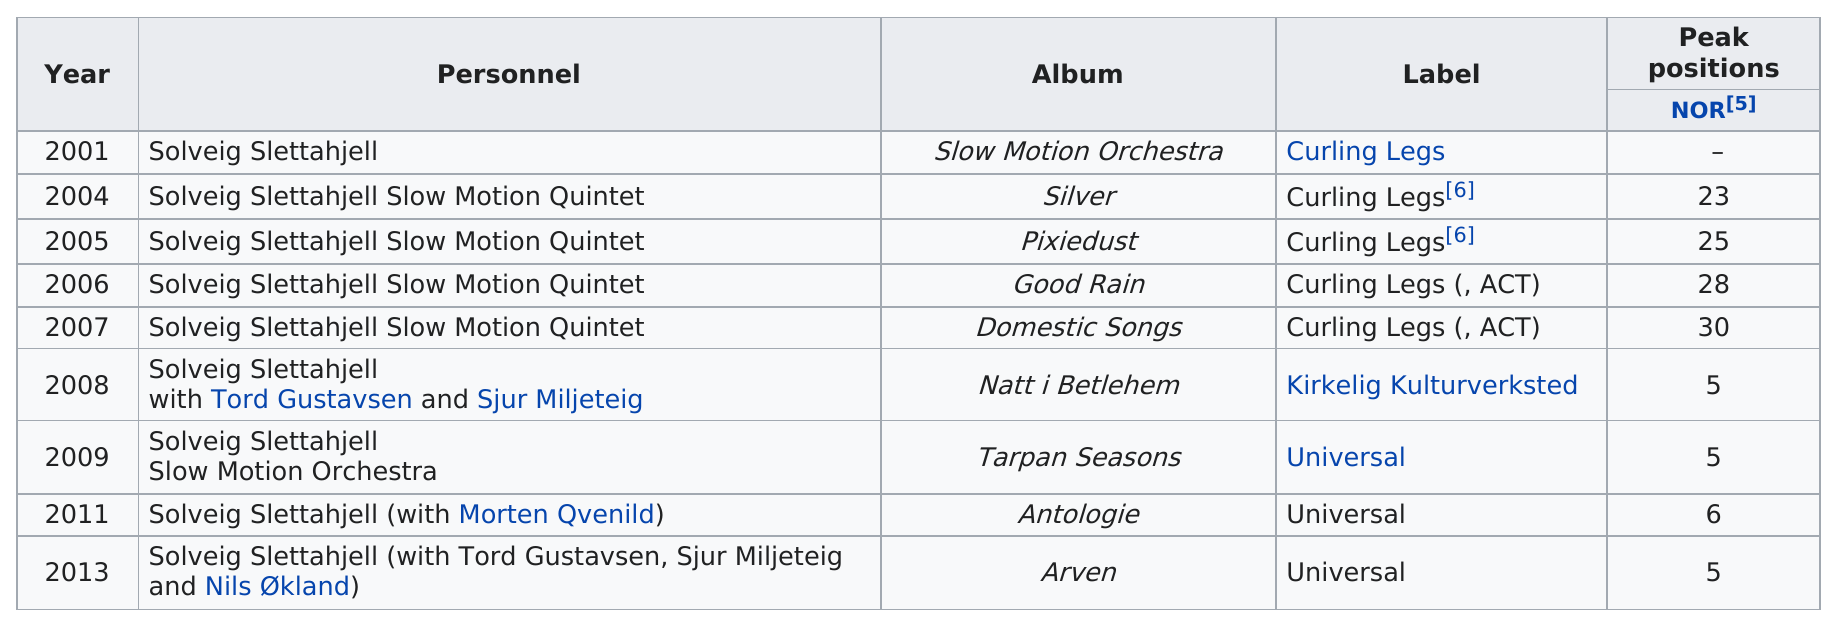Outline some significant characteristics in this image. The subject is unknown. The sentence states that the speaker has heard that a person, who is unknown to them, produced an album before "good rain." The album is called "Pixiedust. In the year 2005 and after, a total of 6 albums were released. The album "Natt i Betlehem" is the first to have peaked in the top ten positions of its respective chart. After Pixiedust, the album that followed was Good Rain. Other than Natt i Betlehem, can you name an album that featured SJUR MILJETEIG?" "Arven" is the correct answer. 